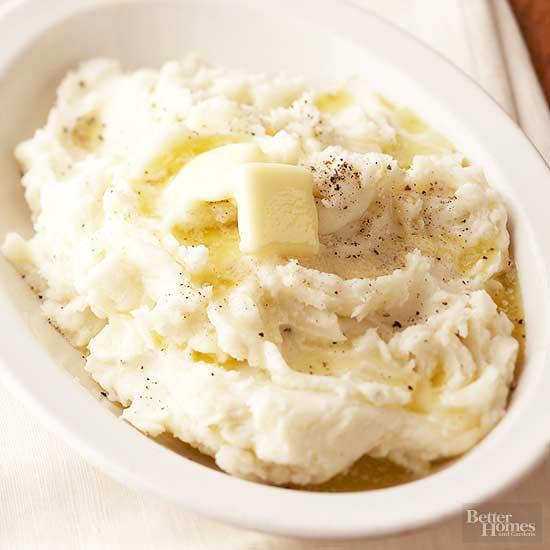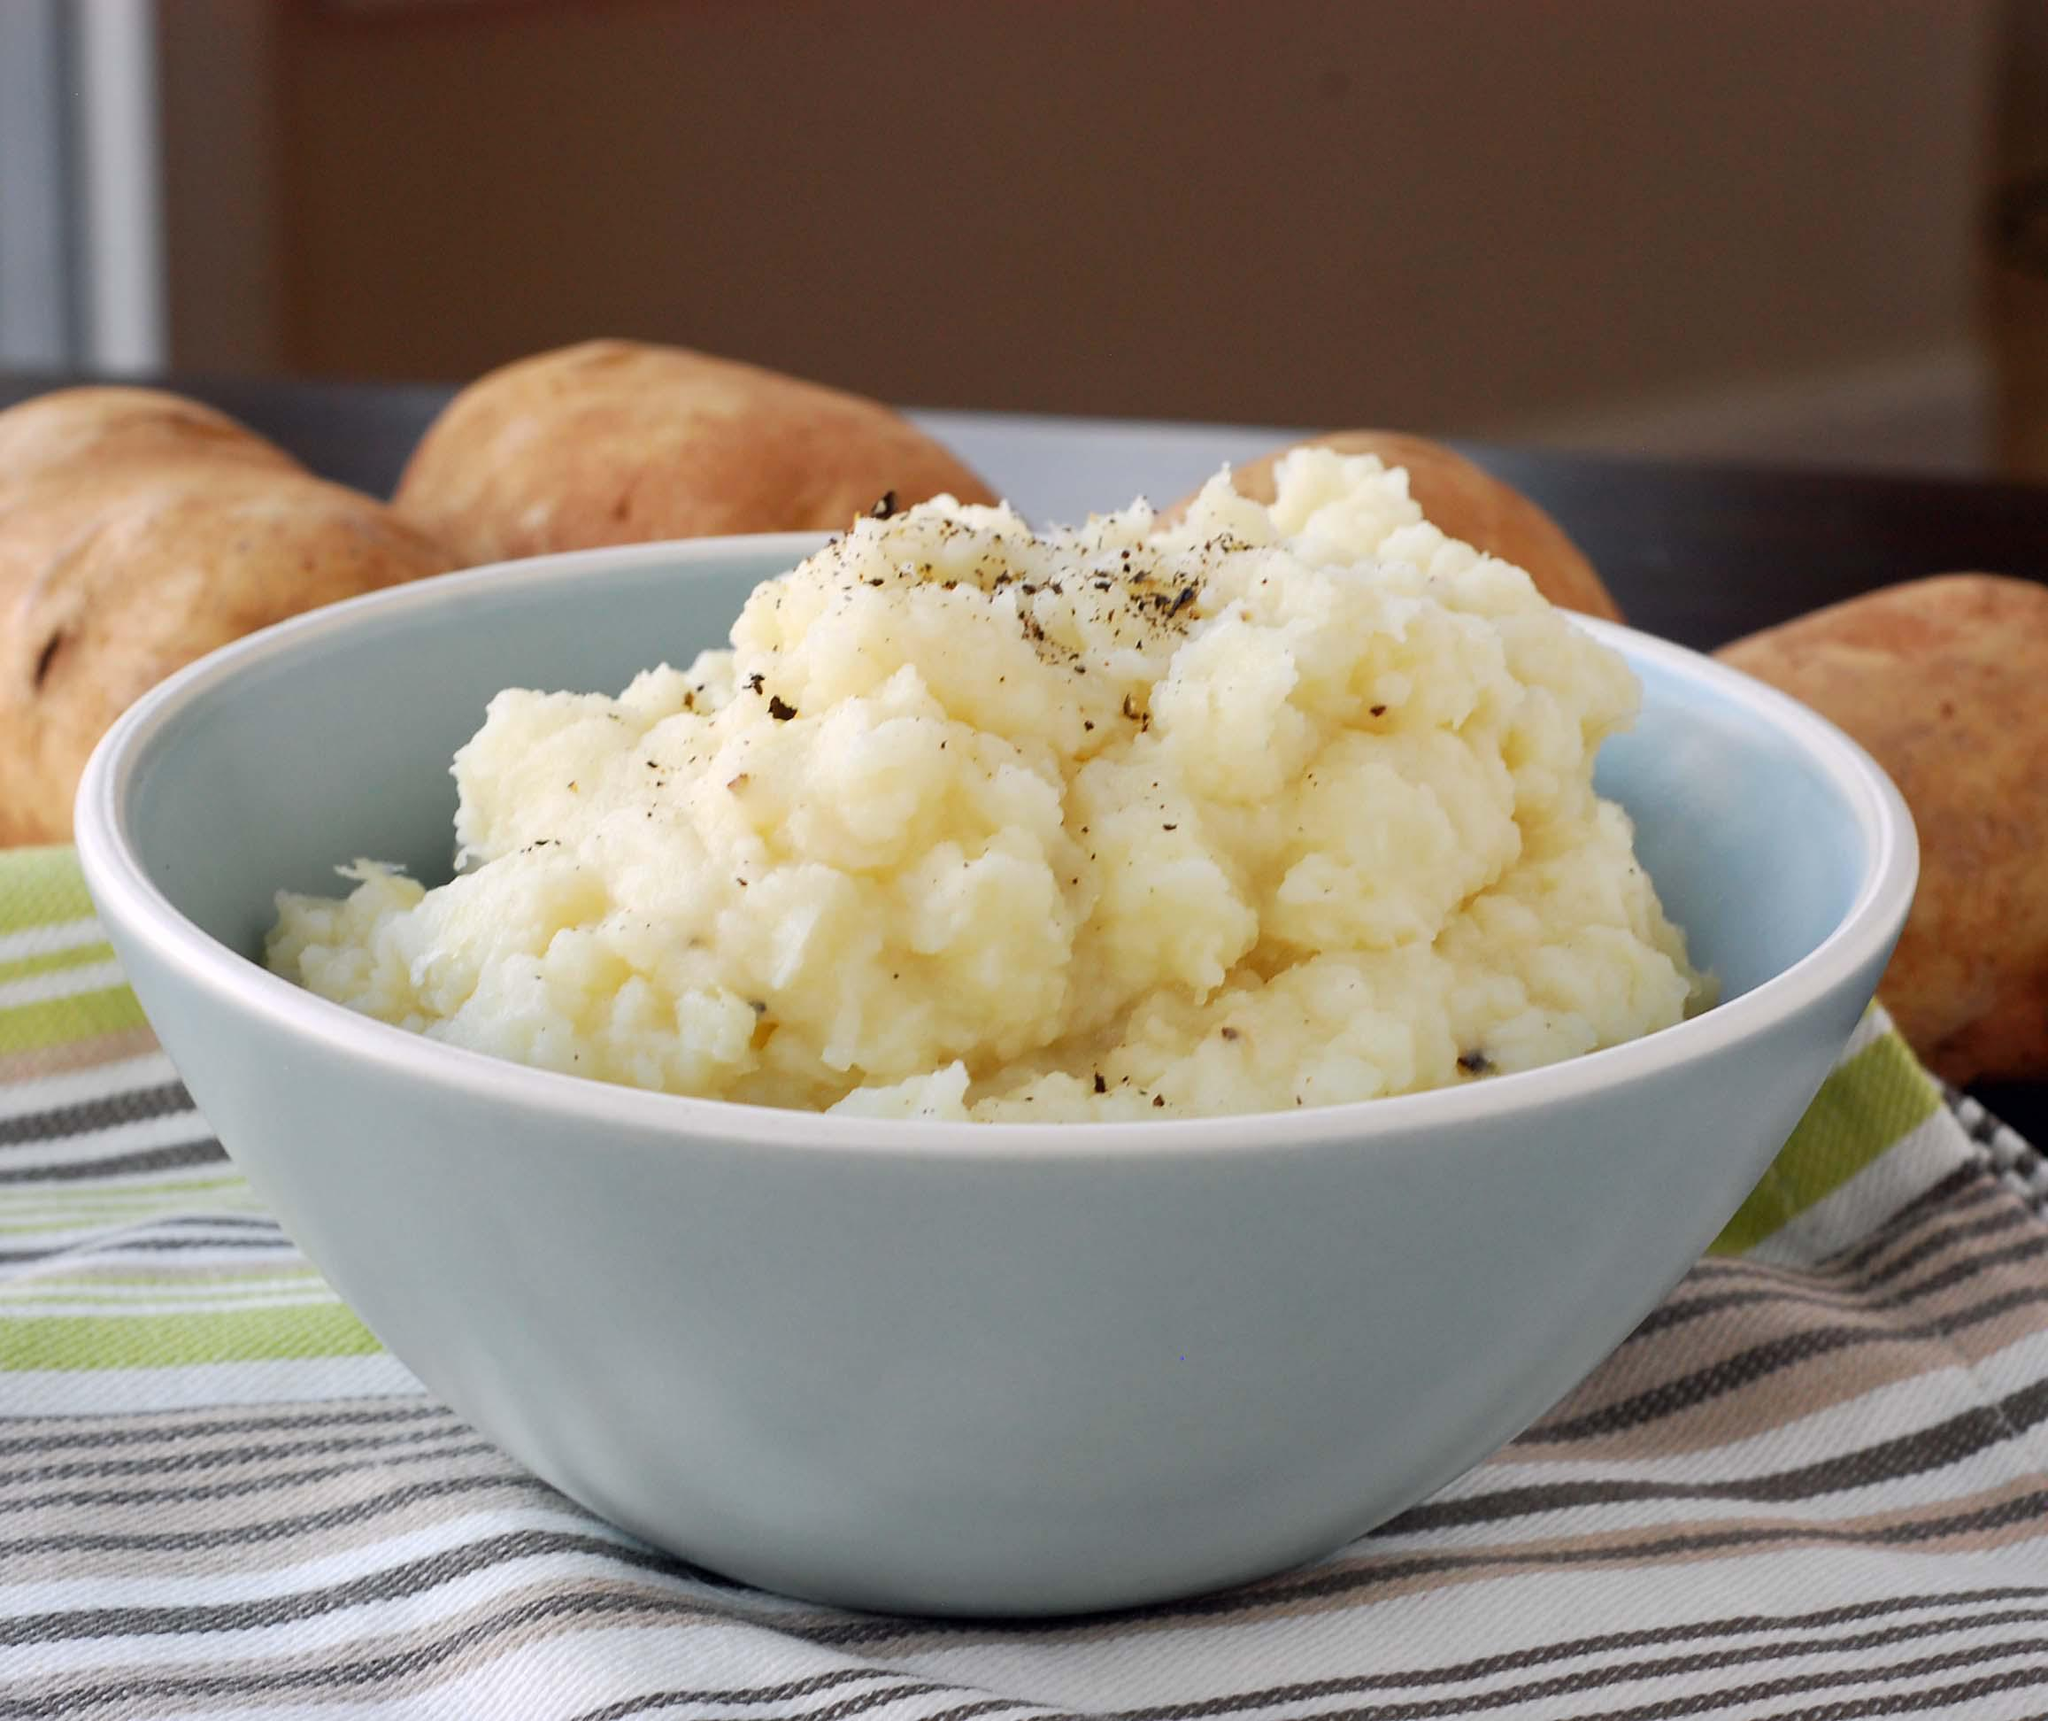The first image is the image on the left, the second image is the image on the right. Assess this claim about the two images: "There is a spoon laying on the table near the bowl in one image.". Correct or not? Answer yes or no. No. The first image is the image on the left, the second image is the image on the right. Examine the images to the left and right. Is the description "A spoon is sitting outside of the bowl of food in one of the images." accurate? Answer yes or no. No. 